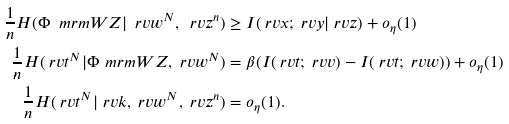Convert formula to latex. <formula><loc_0><loc_0><loc_500><loc_500>\frac { 1 } { n } H ( \Phi _ { \ } m r m { W Z } | \ r v w ^ { N } , \ r v z ^ { n } ) & \geq I ( \ r v x ; \ r v y | \ r v z ) + o _ { \eta } ( 1 ) \\ \frac { 1 } { n } H ( \ r v t ^ { N } | \Phi _ { \ } m r m { W Z } , \ r v w ^ { N } ) & = \beta ( I ( \ r v t ; \ r v v ) - I ( \ r v t ; \ r v w ) ) + o _ { \eta } ( 1 ) \\ \frac { 1 } { n } H ( \ r v t ^ { N } | \ r v k , \ r v w ^ { N } , \ r v z ^ { n } ) & = o _ { \eta } ( 1 ) .</formula> 